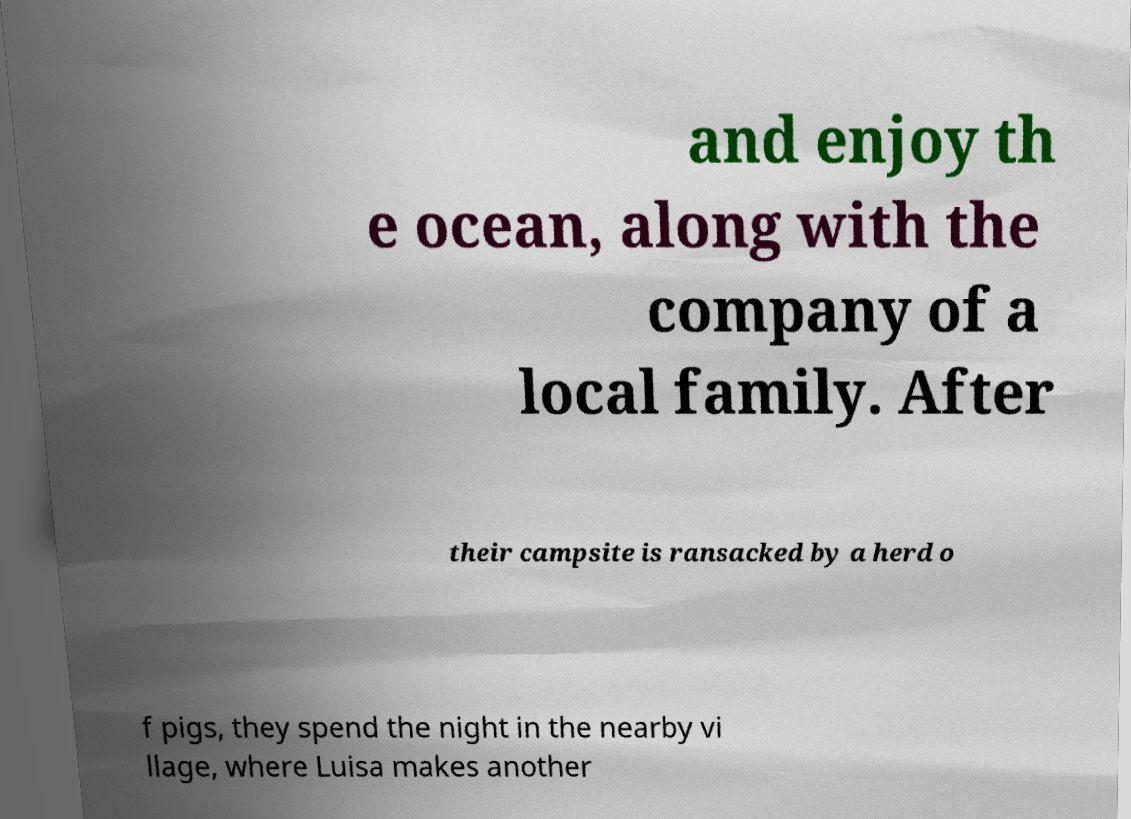For documentation purposes, I need the text within this image transcribed. Could you provide that? and enjoy th e ocean, along with the company of a local family. After their campsite is ransacked by a herd o f pigs, they spend the night in the nearby vi llage, where Luisa makes another 